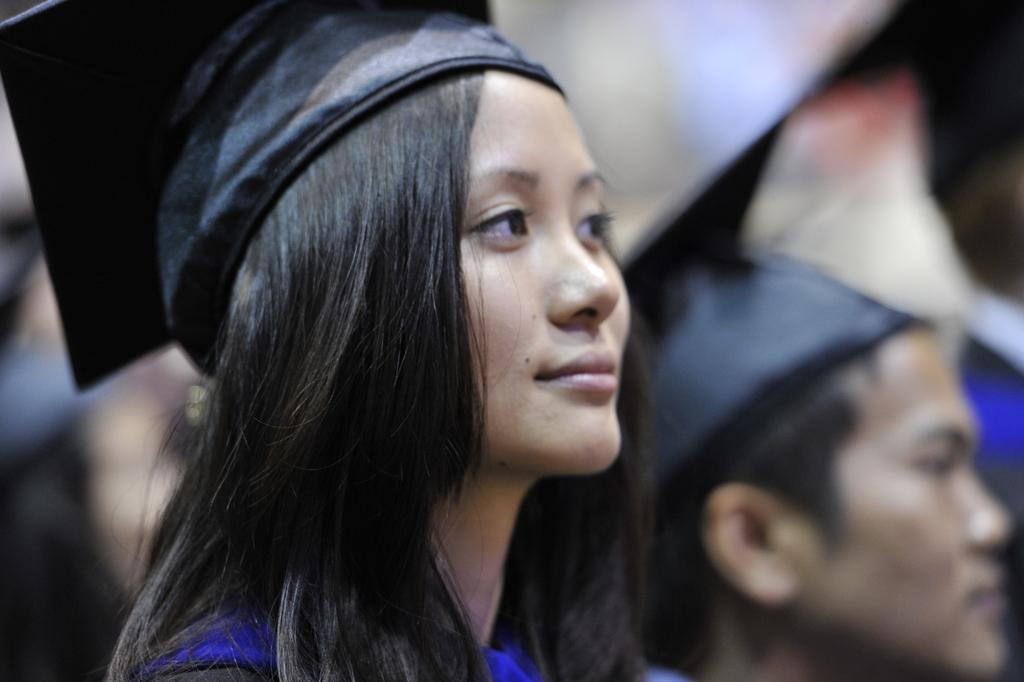Who is the main subject in the image? There is a woman in the image. What is the woman wearing on her head? The woman is wearing a cap. What is the woman's facial expression in the image? The woman is smiling. Can you describe the person in the background of the image? The person in the background is blurry, so it is difficult to provide a detailed description. What is the route the woman is taking in the image? There is no indication of a route in the image, as it only shows the woman and her facial expression. What boundary is visible in the image? There is no boundary visible in the image; it only features the woman and the blurry person in the background. 